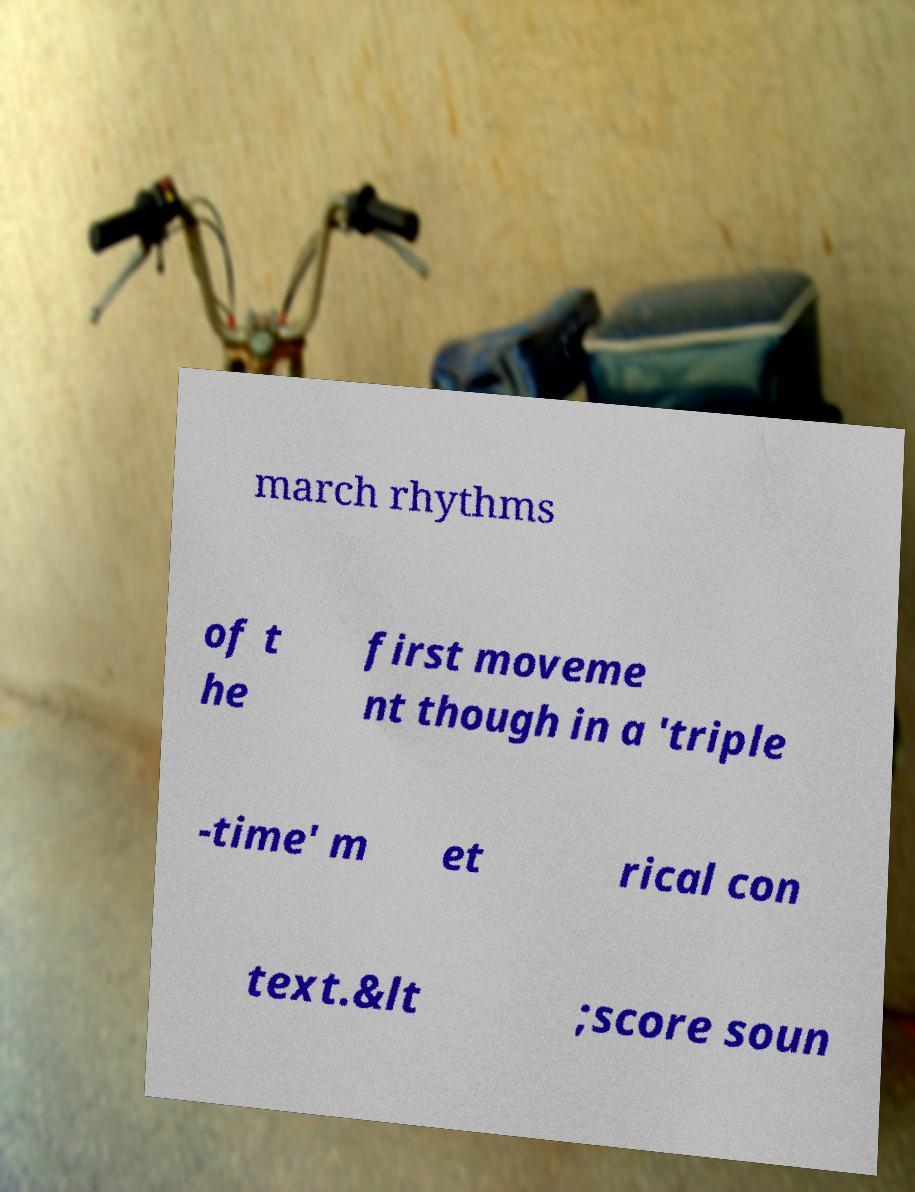Could you extract and type out the text from this image? march rhythms of t he first moveme nt though in a 'triple -time' m et rical con text.&lt ;score soun 